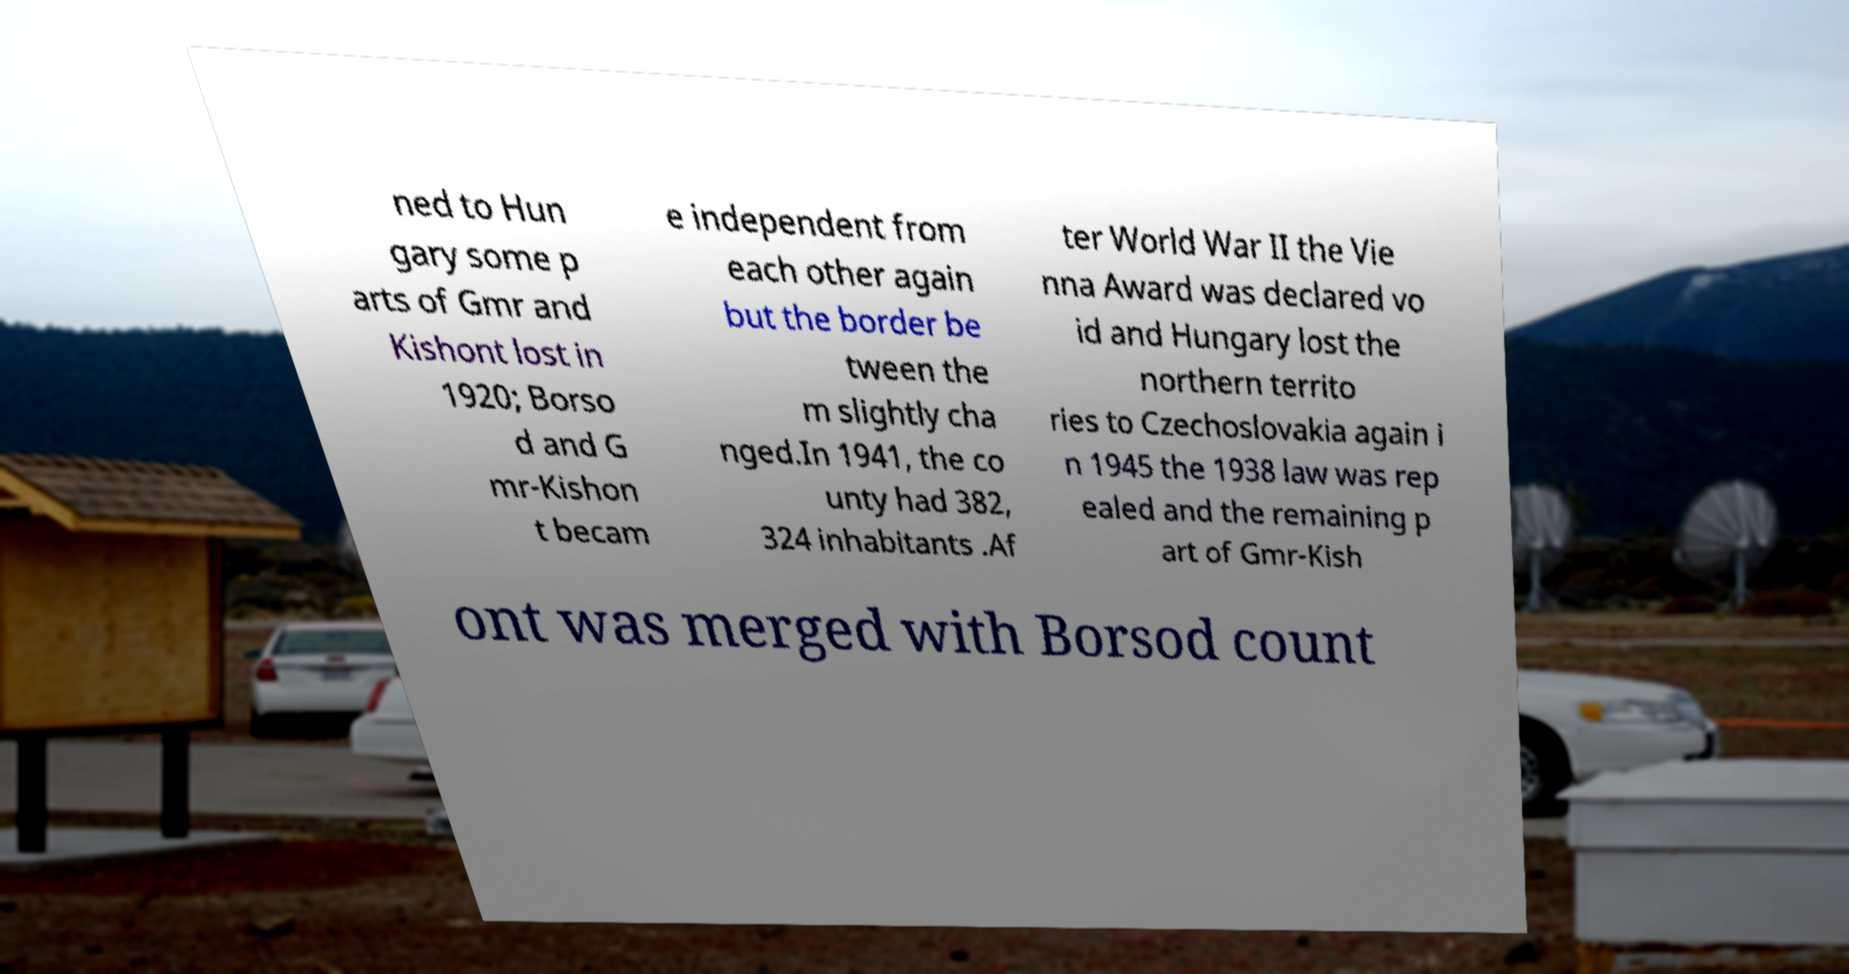Can you accurately transcribe the text from the provided image for me? ned to Hun gary some p arts of Gmr and Kishont lost in 1920; Borso d and G mr-Kishon t becam e independent from each other again but the border be tween the m slightly cha nged.In 1941, the co unty had 382, 324 inhabitants .Af ter World War II the Vie nna Award was declared vo id and Hungary lost the northern territo ries to Czechoslovakia again i n 1945 the 1938 law was rep ealed and the remaining p art of Gmr-Kish ont was merged with Borsod count 